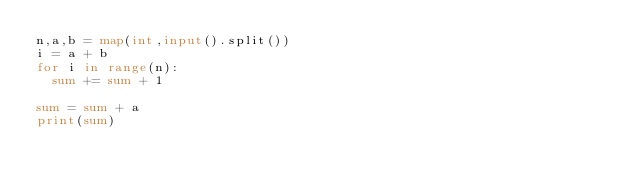<code> <loc_0><loc_0><loc_500><loc_500><_Python_>n,a,b = map(int,input().split())
i = a + b
for i in range(n):
  sum += sum + 1

sum = sum + a
print(sum)</code> 